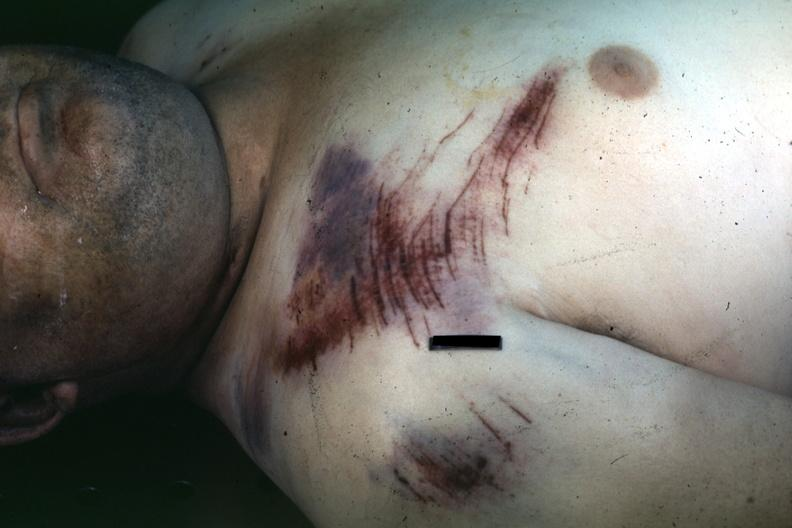how is not the best color white mane with nicely shown lesion about shoulder?
Answer the question using a single word or phrase. Right 